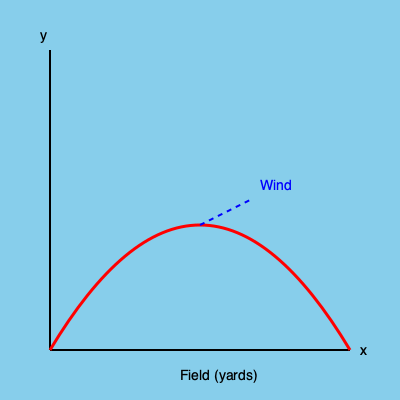As a seasoned Bills fan, you're analyzing a crucial throw from the 1991 Super Bowl. The quarterback launches a pass with an initial velocity of 50 mph at a 45-degree angle. A steady crosswind blows at 15 mph perpendicular to the throw's direction. Assuming no air resistance other than the wind, how far downfield (in yards) will the ball travel before hitting the ground? Let's break this down step-by-step:

1) First, we need to consider the components of the throw without wind:
   - Initial velocity: $v_0 = 50$ mph ≈ 22.35 m/s
   - Angle: $\theta = 45°$

2) The horizontal and vertical components of the velocity are:
   $v_x = v_0 \cos(\theta) = 22.35 \cdot \cos(45°) ≈ 15.8$ m/s
   $v_y = v_0 \sin(\theta) = 22.35 \cdot \sin(45°) ≈ 15.8$ m/s

3) The time of flight without wind would be:
   $t = \frac{2v_y}{g} = \frac{2 \cdot 15.8}{9.8} ≈ 3.22$ seconds

4) Now, let's factor in the wind:
   Wind speed: 15 mph ≈ 6.7 m/s

5) The wind will affect the horizontal distance. The total horizontal displacement is:
   $x = v_x t + \frac{1}{2} a_w t^2$
   Where $a_w$ is the acceleration due to wind: $a_w = \frac{6.7}{3.22} ≈ 2.08$ m/s²

6) Plugging in the values:
   $x = (15.8 \cdot 3.22) + (\frac{1}{2} \cdot 2.08 \cdot 3.22^2) ≈ 51.0 + 10.8 = 61.8$ meters

7) Converting to yards:
   61.8 meters ≈ 67.6 yards

Therefore, the ball will travel approximately 68 yards downfield.
Answer: 68 yards 